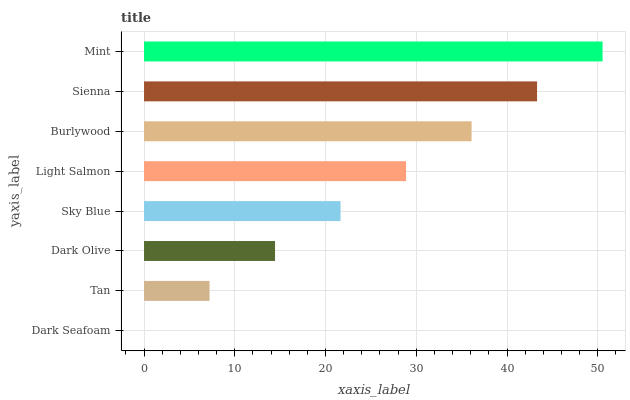Is Dark Seafoam the minimum?
Answer yes or no. Yes. Is Mint the maximum?
Answer yes or no. Yes. Is Tan the minimum?
Answer yes or no. No. Is Tan the maximum?
Answer yes or no. No. Is Tan greater than Dark Seafoam?
Answer yes or no. Yes. Is Dark Seafoam less than Tan?
Answer yes or no. Yes. Is Dark Seafoam greater than Tan?
Answer yes or no. No. Is Tan less than Dark Seafoam?
Answer yes or no. No. Is Light Salmon the high median?
Answer yes or no. Yes. Is Sky Blue the low median?
Answer yes or no. Yes. Is Dark Olive the high median?
Answer yes or no. No. Is Sienna the low median?
Answer yes or no. No. 